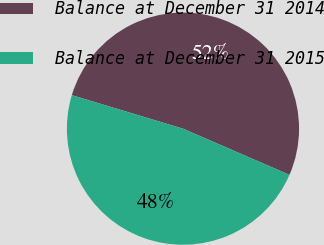<chart> <loc_0><loc_0><loc_500><loc_500><pie_chart><fcel>Balance at December 31 2014<fcel>Balance at December 31 2015<nl><fcel>51.85%<fcel>48.15%<nl></chart> 